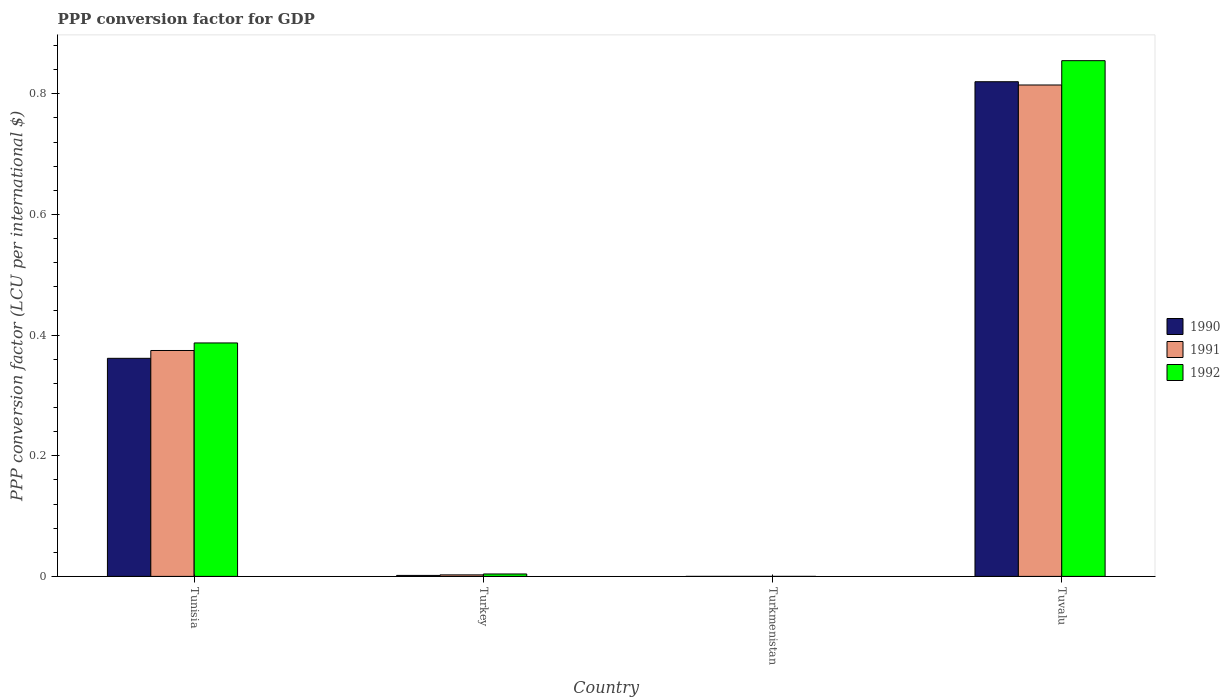How many groups of bars are there?
Keep it short and to the point. 4. Are the number of bars per tick equal to the number of legend labels?
Offer a terse response. Yes. How many bars are there on the 1st tick from the left?
Your answer should be compact. 3. How many bars are there on the 4th tick from the right?
Ensure brevity in your answer.  3. What is the label of the 3rd group of bars from the left?
Make the answer very short. Turkmenistan. What is the PPP conversion factor for GDP in 1992 in Tuvalu?
Your response must be concise. 0.85. Across all countries, what is the maximum PPP conversion factor for GDP in 1992?
Your answer should be compact. 0.85. Across all countries, what is the minimum PPP conversion factor for GDP in 1992?
Offer a terse response. 9.4244319432505e-6. In which country was the PPP conversion factor for GDP in 1990 maximum?
Your answer should be compact. Tuvalu. In which country was the PPP conversion factor for GDP in 1992 minimum?
Provide a succinct answer. Turkmenistan. What is the total PPP conversion factor for GDP in 1990 in the graph?
Provide a succinct answer. 1.18. What is the difference between the PPP conversion factor for GDP in 1992 in Turkey and that in Turkmenistan?
Provide a succinct answer. 0. What is the difference between the PPP conversion factor for GDP in 1992 in Turkey and the PPP conversion factor for GDP in 1991 in Tuvalu?
Provide a succinct answer. -0.81. What is the average PPP conversion factor for GDP in 1992 per country?
Ensure brevity in your answer.  0.31. What is the difference between the PPP conversion factor for GDP of/in 1992 and PPP conversion factor for GDP of/in 1990 in Turkey?
Ensure brevity in your answer.  0. What is the ratio of the PPP conversion factor for GDP in 1990 in Turkmenistan to that in Tuvalu?
Offer a very short reply. 1.8722904444335625e-7. Is the difference between the PPP conversion factor for GDP in 1992 in Tunisia and Tuvalu greater than the difference between the PPP conversion factor for GDP in 1990 in Tunisia and Tuvalu?
Provide a succinct answer. No. What is the difference between the highest and the second highest PPP conversion factor for GDP in 1990?
Offer a very short reply. 0.46. What is the difference between the highest and the lowest PPP conversion factor for GDP in 1990?
Your answer should be very brief. 0.82. In how many countries, is the PPP conversion factor for GDP in 1990 greater than the average PPP conversion factor for GDP in 1990 taken over all countries?
Give a very brief answer. 2. Is the sum of the PPP conversion factor for GDP in 1991 in Tunisia and Turkmenistan greater than the maximum PPP conversion factor for GDP in 1992 across all countries?
Offer a terse response. No. What does the 2nd bar from the left in Tuvalu represents?
Your answer should be compact. 1991. What does the 2nd bar from the right in Tuvalu represents?
Your answer should be very brief. 1991. Are all the bars in the graph horizontal?
Provide a succinct answer. No. How many countries are there in the graph?
Give a very brief answer. 4. Are the values on the major ticks of Y-axis written in scientific E-notation?
Your answer should be compact. No. Does the graph contain grids?
Provide a succinct answer. No. Where does the legend appear in the graph?
Give a very brief answer. Center right. How many legend labels are there?
Your answer should be compact. 3. What is the title of the graph?
Your answer should be very brief. PPP conversion factor for GDP. What is the label or title of the X-axis?
Offer a terse response. Country. What is the label or title of the Y-axis?
Provide a succinct answer. PPP conversion factor (LCU per international $). What is the PPP conversion factor (LCU per international $) of 1990 in Tunisia?
Make the answer very short. 0.36. What is the PPP conversion factor (LCU per international $) of 1991 in Tunisia?
Offer a very short reply. 0.37. What is the PPP conversion factor (LCU per international $) in 1992 in Tunisia?
Make the answer very short. 0.39. What is the PPP conversion factor (LCU per international $) of 1990 in Turkey?
Keep it short and to the point. 0. What is the PPP conversion factor (LCU per international $) in 1991 in Turkey?
Provide a short and direct response. 0. What is the PPP conversion factor (LCU per international $) of 1992 in Turkey?
Keep it short and to the point. 0. What is the PPP conversion factor (LCU per international $) in 1990 in Turkmenistan?
Keep it short and to the point. 1.53509362101671e-7. What is the PPP conversion factor (LCU per international $) of 1991 in Turkmenistan?
Make the answer very short. 3.01227082389115e-7. What is the PPP conversion factor (LCU per international $) in 1992 in Turkmenistan?
Your answer should be compact. 9.4244319432505e-6. What is the PPP conversion factor (LCU per international $) in 1990 in Tuvalu?
Provide a succinct answer. 0.82. What is the PPP conversion factor (LCU per international $) in 1991 in Tuvalu?
Your response must be concise. 0.81. What is the PPP conversion factor (LCU per international $) of 1992 in Tuvalu?
Keep it short and to the point. 0.85. Across all countries, what is the maximum PPP conversion factor (LCU per international $) in 1990?
Make the answer very short. 0.82. Across all countries, what is the maximum PPP conversion factor (LCU per international $) of 1991?
Your response must be concise. 0.81. Across all countries, what is the maximum PPP conversion factor (LCU per international $) of 1992?
Your response must be concise. 0.85. Across all countries, what is the minimum PPP conversion factor (LCU per international $) in 1990?
Ensure brevity in your answer.  1.53509362101671e-7. Across all countries, what is the minimum PPP conversion factor (LCU per international $) of 1991?
Make the answer very short. 3.01227082389115e-7. Across all countries, what is the minimum PPP conversion factor (LCU per international $) of 1992?
Make the answer very short. 9.4244319432505e-6. What is the total PPP conversion factor (LCU per international $) in 1990 in the graph?
Provide a short and direct response. 1.18. What is the total PPP conversion factor (LCU per international $) of 1991 in the graph?
Your response must be concise. 1.19. What is the total PPP conversion factor (LCU per international $) in 1992 in the graph?
Your answer should be compact. 1.25. What is the difference between the PPP conversion factor (LCU per international $) of 1990 in Tunisia and that in Turkey?
Make the answer very short. 0.36. What is the difference between the PPP conversion factor (LCU per international $) of 1991 in Tunisia and that in Turkey?
Offer a very short reply. 0.37. What is the difference between the PPP conversion factor (LCU per international $) in 1992 in Tunisia and that in Turkey?
Your answer should be compact. 0.38. What is the difference between the PPP conversion factor (LCU per international $) of 1990 in Tunisia and that in Turkmenistan?
Provide a short and direct response. 0.36. What is the difference between the PPP conversion factor (LCU per international $) of 1991 in Tunisia and that in Turkmenistan?
Offer a very short reply. 0.37. What is the difference between the PPP conversion factor (LCU per international $) of 1992 in Tunisia and that in Turkmenistan?
Provide a short and direct response. 0.39. What is the difference between the PPP conversion factor (LCU per international $) in 1990 in Tunisia and that in Tuvalu?
Give a very brief answer. -0.46. What is the difference between the PPP conversion factor (LCU per international $) in 1991 in Tunisia and that in Tuvalu?
Provide a short and direct response. -0.44. What is the difference between the PPP conversion factor (LCU per international $) of 1992 in Tunisia and that in Tuvalu?
Your response must be concise. -0.47. What is the difference between the PPP conversion factor (LCU per international $) of 1990 in Turkey and that in Turkmenistan?
Provide a short and direct response. 0. What is the difference between the PPP conversion factor (LCU per international $) of 1991 in Turkey and that in Turkmenistan?
Make the answer very short. 0. What is the difference between the PPP conversion factor (LCU per international $) in 1992 in Turkey and that in Turkmenistan?
Your response must be concise. 0. What is the difference between the PPP conversion factor (LCU per international $) of 1990 in Turkey and that in Tuvalu?
Keep it short and to the point. -0.82. What is the difference between the PPP conversion factor (LCU per international $) of 1991 in Turkey and that in Tuvalu?
Ensure brevity in your answer.  -0.81. What is the difference between the PPP conversion factor (LCU per international $) of 1992 in Turkey and that in Tuvalu?
Provide a succinct answer. -0.85. What is the difference between the PPP conversion factor (LCU per international $) in 1990 in Turkmenistan and that in Tuvalu?
Provide a succinct answer. -0.82. What is the difference between the PPP conversion factor (LCU per international $) in 1991 in Turkmenistan and that in Tuvalu?
Keep it short and to the point. -0.81. What is the difference between the PPP conversion factor (LCU per international $) in 1992 in Turkmenistan and that in Tuvalu?
Keep it short and to the point. -0.85. What is the difference between the PPP conversion factor (LCU per international $) in 1990 in Tunisia and the PPP conversion factor (LCU per international $) in 1991 in Turkey?
Provide a succinct answer. 0.36. What is the difference between the PPP conversion factor (LCU per international $) of 1990 in Tunisia and the PPP conversion factor (LCU per international $) of 1992 in Turkey?
Make the answer very short. 0.36. What is the difference between the PPP conversion factor (LCU per international $) of 1991 in Tunisia and the PPP conversion factor (LCU per international $) of 1992 in Turkey?
Provide a succinct answer. 0.37. What is the difference between the PPP conversion factor (LCU per international $) of 1990 in Tunisia and the PPP conversion factor (LCU per international $) of 1991 in Turkmenistan?
Your answer should be very brief. 0.36. What is the difference between the PPP conversion factor (LCU per international $) of 1990 in Tunisia and the PPP conversion factor (LCU per international $) of 1992 in Turkmenistan?
Ensure brevity in your answer.  0.36. What is the difference between the PPP conversion factor (LCU per international $) in 1991 in Tunisia and the PPP conversion factor (LCU per international $) in 1992 in Turkmenistan?
Your answer should be compact. 0.37. What is the difference between the PPP conversion factor (LCU per international $) of 1990 in Tunisia and the PPP conversion factor (LCU per international $) of 1991 in Tuvalu?
Your answer should be very brief. -0.45. What is the difference between the PPP conversion factor (LCU per international $) of 1990 in Tunisia and the PPP conversion factor (LCU per international $) of 1992 in Tuvalu?
Keep it short and to the point. -0.49. What is the difference between the PPP conversion factor (LCU per international $) in 1991 in Tunisia and the PPP conversion factor (LCU per international $) in 1992 in Tuvalu?
Ensure brevity in your answer.  -0.48. What is the difference between the PPP conversion factor (LCU per international $) in 1990 in Turkey and the PPP conversion factor (LCU per international $) in 1991 in Turkmenistan?
Your answer should be very brief. 0. What is the difference between the PPP conversion factor (LCU per international $) in 1990 in Turkey and the PPP conversion factor (LCU per international $) in 1992 in Turkmenistan?
Your response must be concise. 0. What is the difference between the PPP conversion factor (LCU per international $) in 1991 in Turkey and the PPP conversion factor (LCU per international $) in 1992 in Turkmenistan?
Keep it short and to the point. 0. What is the difference between the PPP conversion factor (LCU per international $) in 1990 in Turkey and the PPP conversion factor (LCU per international $) in 1991 in Tuvalu?
Your answer should be very brief. -0.81. What is the difference between the PPP conversion factor (LCU per international $) of 1990 in Turkey and the PPP conversion factor (LCU per international $) of 1992 in Tuvalu?
Offer a very short reply. -0.85. What is the difference between the PPP conversion factor (LCU per international $) in 1991 in Turkey and the PPP conversion factor (LCU per international $) in 1992 in Tuvalu?
Keep it short and to the point. -0.85. What is the difference between the PPP conversion factor (LCU per international $) of 1990 in Turkmenistan and the PPP conversion factor (LCU per international $) of 1991 in Tuvalu?
Give a very brief answer. -0.81. What is the difference between the PPP conversion factor (LCU per international $) in 1990 in Turkmenistan and the PPP conversion factor (LCU per international $) in 1992 in Tuvalu?
Your response must be concise. -0.85. What is the difference between the PPP conversion factor (LCU per international $) in 1991 in Turkmenistan and the PPP conversion factor (LCU per international $) in 1992 in Tuvalu?
Provide a short and direct response. -0.85. What is the average PPP conversion factor (LCU per international $) in 1990 per country?
Make the answer very short. 0.3. What is the average PPP conversion factor (LCU per international $) of 1991 per country?
Offer a terse response. 0.3. What is the average PPP conversion factor (LCU per international $) in 1992 per country?
Your answer should be very brief. 0.31. What is the difference between the PPP conversion factor (LCU per international $) of 1990 and PPP conversion factor (LCU per international $) of 1991 in Tunisia?
Give a very brief answer. -0.01. What is the difference between the PPP conversion factor (LCU per international $) of 1990 and PPP conversion factor (LCU per international $) of 1992 in Tunisia?
Your answer should be compact. -0.03. What is the difference between the PPP conversion factor (LCU per international $) in 1991 and PPP conversion factor (LCU per international $) in 1992 in Tunisia?
Give a very brief answer. -0.01. What is the difference between the PPP conversion factor (LCU per international $) of 1990 and PPP conversion factor (LCU per international $) of 1991 in Turkey?
Your answer should be compact. -0. What is the difference between the PPP conversion factor (LCU per international $) of 1990 and PPP conversion factor (LCU per international $) of 1992 in Turkey?
Keep it short and to the point. -0. What is the difference between the PPP conversion factor (LCU per international $) in 1991 and PPP conversion factor (LCU per international $) in 1992 in Turkey?
Your answer should be compact. -0. What is the difference between the PPP conversion factor (LCU per international $) in 1990 and PPP conversion factor (LCU per international $) in 1991 in Turkmenistan?
Provide a short and direct response. -0. What is the difference between the PPP conversion factor (LCU per international $) in 1991 and PPP conversion factor (LCU per international $) in 1992 in Turkmenistan?
Offer a terse response. -0. What is the difference between the PPP conversion factor (LCU per international $) in 1990 and PPP conversion factor (LCU per international $) in 1991 in Tuvalu?
Make the answer very short. 0.01. What is the difference between the PPP conversion factor (LCU per international $) in 1990 and PPP conversion factor (LCU per international $) in 1992 in Tuvalu?
Make the answer very short. -0.03. What is the difference between the PPP conversion factor (LCU per international $) of 1991 and PPP conversion factor (LCU per international $) of 1992 in Tuvalu?
Keep it short and to the point. -0.04. What is the ratio of the PPP conversion factor (LCU per international $) in 1990 in Tunisia to that in Turkey?
Provide a short and direct response. 220.68. What is the ratio of the PPP conversion factor (LCU per international $) of 1991 in Tunisia to that in Turkey?
Offer a very short reply. 148.71. What is the ratio of the PPP conversion factor (LCU per international $) in 1992 in Tunisia to that in Turkey?
Give a very brief answer. 96.01. What is the ratio of the PPP conversion factor (LCU per international $) of 1990 in Tunisia to that in Turkmenistan?
Your response must be concise. 2.35e+06. What is the ratio of the PPP conversion factor (LCU per international $) of 1991 in Tunisia to that in Turkmenistan?
Provide a short and direct response. 1.24e+06. What is the ratio of the PPP conversion factor (LCU per international $) of 1992 in Tunisia to that in Turkmenistan?
Your response must be concise. 4.11e+04. What is the ratio of the PPP conversion factor (LCU per international $) of 1990 in Tunisia to that in Tuvalu?
Your answer should be compact. 0.44. What is the ratio of the PPP conversion factor (LCU per international $) of 1991 in Tunisia to that in Tuvalu?
Keep it short and to the point. 0.46. What is the ratio of the PPP conversion factor (LCU per international $) of 1992 in Tunisia to that in Tuvalu?
Give a very brief answer. 0.45. What is the ratio of the PPP conversion factor (LCU per international $) in 1990 in Turkey to that in Turkmenistan?
Keep it short and to the point. 1.07e+04. What is the ratio of the PPP conversion factor (LCU per international $) of 1991 in Turkey to that in Turkmenistan?
Offer a terse response. 8359.14. What is the ratio of the PPP conversion factor (LCU per international $) of 1992 in Turkey to that in Turkmenistan?
Provide a short and direct response. 427.61. What is the ratio of the PPP conversion factor (LCU per international $) in 1990 in Turkey to that in Tuvalu?
Offer a very short reply. 0. What is the ratio of the PPP conversion factor (LCU per international $) of 1991 in Turkey to that in Tuvalu?
Your answer should be compact. 0. What is the ratio of the PPP conversion factor (LCU per international $) of 1992 in Turkey to that in Tuvalu?
Offer a terse response. 0. What is the ratio of the PPP conversion factor (LCU per international $) of 1991 in Turkmenistan to that in Tuvalu?
Offer a terse response. 0. What is the difference between the highest and the second highest PPP conversion factor (LCU per international $) in 1990?
Give a very brief answer. 0.46. What is the difference between the highest and the second highest PPP conversion factor (LCU per international $) in 1991?
Provide a short and direct response. 0.44. What is the difference between the highest and the second highest PPP conversion factor (LCU per international $) in 1992?
Offer a very short reply. 0.47. What is the difference between the highest and the lowest PPP conversion factor (LCU per international $) in 1990?
Give a very brief answer. 0.82. What is the difference between the highest and the lowest PPP conversion factor (LCU per international $) in 1991?
Provide a short and direct response. 0.81. What is the difference between the highest and the lowest PPP conversion factor (LCU per international $) of 1992?
Your answer should be compact. 0.85. 